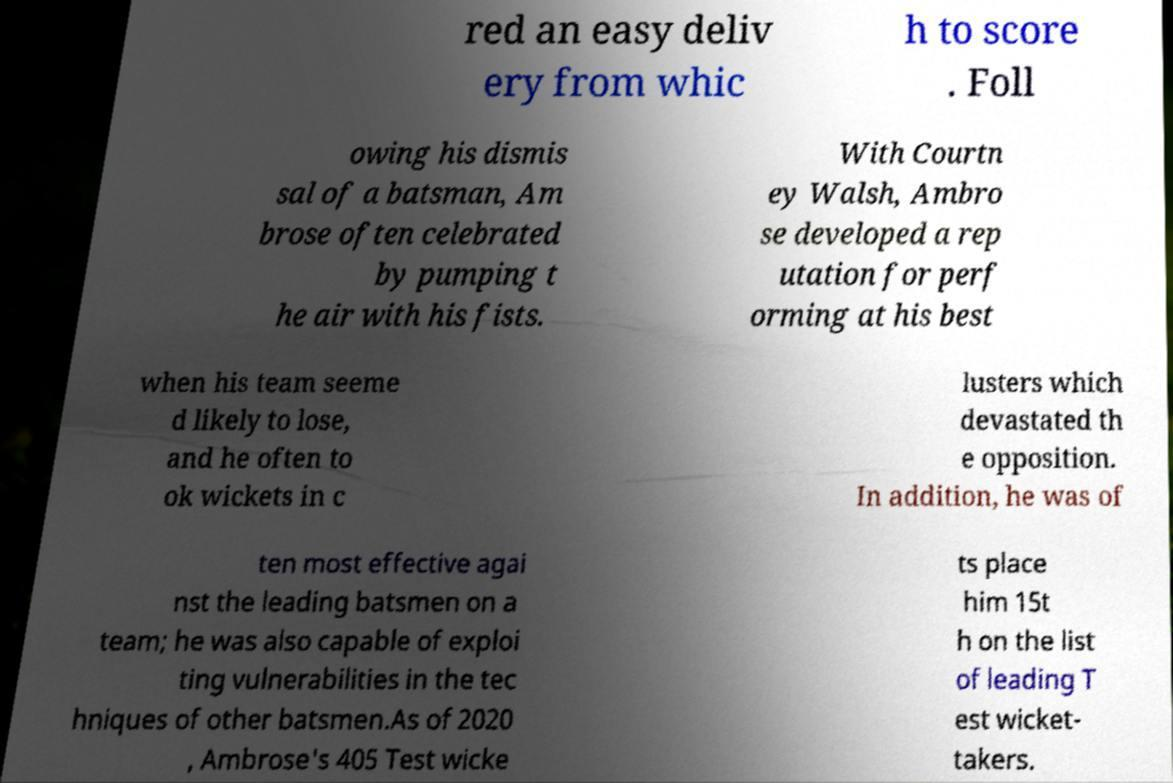Please identify and transcribe the text found in this image. red an easy deliv ery from whic h to score . Foll owing his dismis sal of a batsman, Am brose often celebrated by pumping t he air with his fists. With Courtn ey Walsh, Ambro se developed a rep utation for perf orming at his best when his team seeme d likely to lose, and he often to ok wickets in c lusters which devastated th e opposition. In addition, he was of ten most effective agai nst the leading batsmen on a team; he was also capable of exploi ting vulnerabilities in the tec hniques of other batsmen.As of 2020 , Ambrose's 405 Test wicke ts place him 15t h on the list of leading T est wicket- takers. 